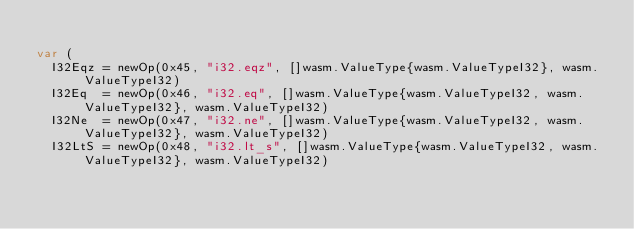Convert code to text. <code><loc_0><loc_0><loc_500><loc_500><_Go_>
var (
	I32Eqz = newOp(0x45, "i32.eqz", []wasm.ValueType{wasm.ValueTypeI32}, wasm.ValueTypeI32)
	I32Eq  = newOp(0x46, "i32.eq", []wasm.ValueType{wasm.ValueTypeI32, wasm.ValueTypeI32}, wasm.ValueTypeI32)
	I32Ne  = newOp(0x47, "i32.ne", []wasm.ValueType{wasm.ValueTypeI32, wasm.ValueTypeI32}, wasm.ValueTypeI32)
	I32LtS = newOp(0x48, "i32.lt_s", []wasm.ValueType{wasm.ValueTypeI32, wasm.ValueTypeI32}, wasm.ValueTypeI32)</code> 